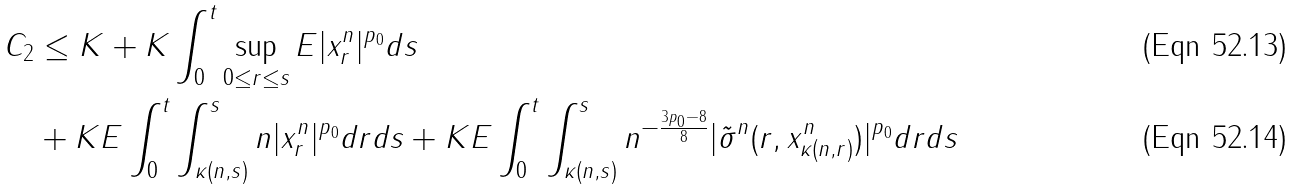<formula> <loc_0><loc_0><loc_500><loc_500>C _ { 2 } & \leq K + K \int _ { 0 } ^ { t } \sup _ { 0 \leq r \leq s } E | x _ { r } ^ { n } | ^ { p _ { 0 } } d s \\ & + K E \int _ { 0 } ^ { t } \int _ { \kappa ( n , s ) } ^ { s } n | x _ { r } ^ { n } | ^ { p _ { 0 } } d r d s + K E \int _ { 0 } ^ { t } \int _ { \kappa ( n , s ) } ^ { s } n ^ { - \frac { 3 p _ { 0 } - 8 } { 8 } } | \tilde { \sigma } ^ { n } ( r , x _ { \kappa ( n , r ) } ^ { n } ) | ^ { p _ { 0 } } d r d s</formula> 